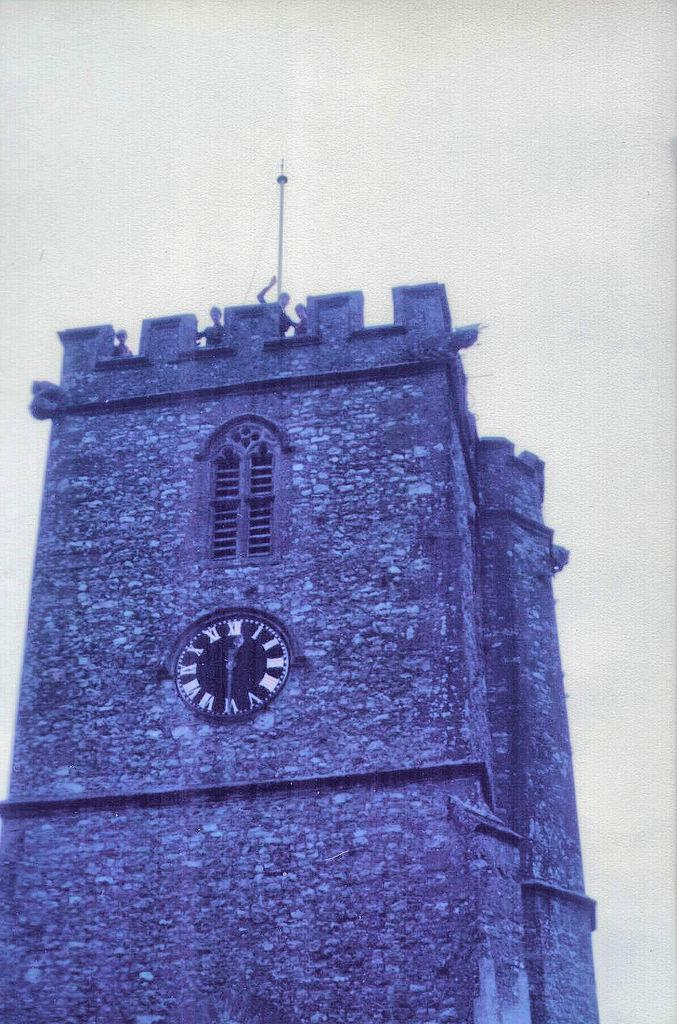What is the main subject of the image? The main subject of the image is a construction site. What can be seen in the center of the image? There is a clock and a window in the center of the image. Are there any people visible in the image? Yes, there are people visible at the top of a building in the image. What number is the beggar holding in the image? There is no beggar present in the image, so there is no number being held. 